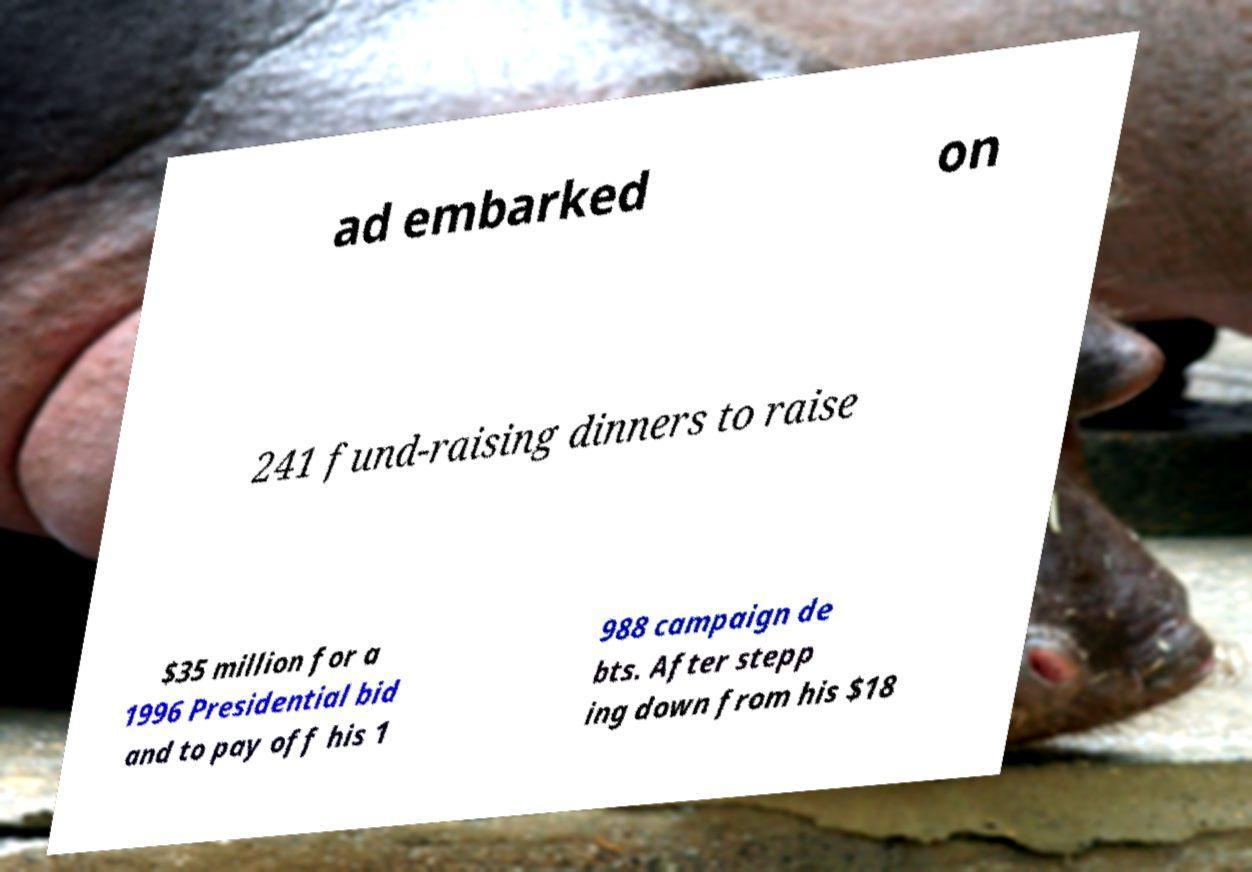Please read and relay the text visible in this image. What does it say? ad embarked on 241 fund-raising dinners to raise $35 million for a 1996 Presidential bid and to pay off his 1 988 campaign de bts. After stepp ing down from his $18 